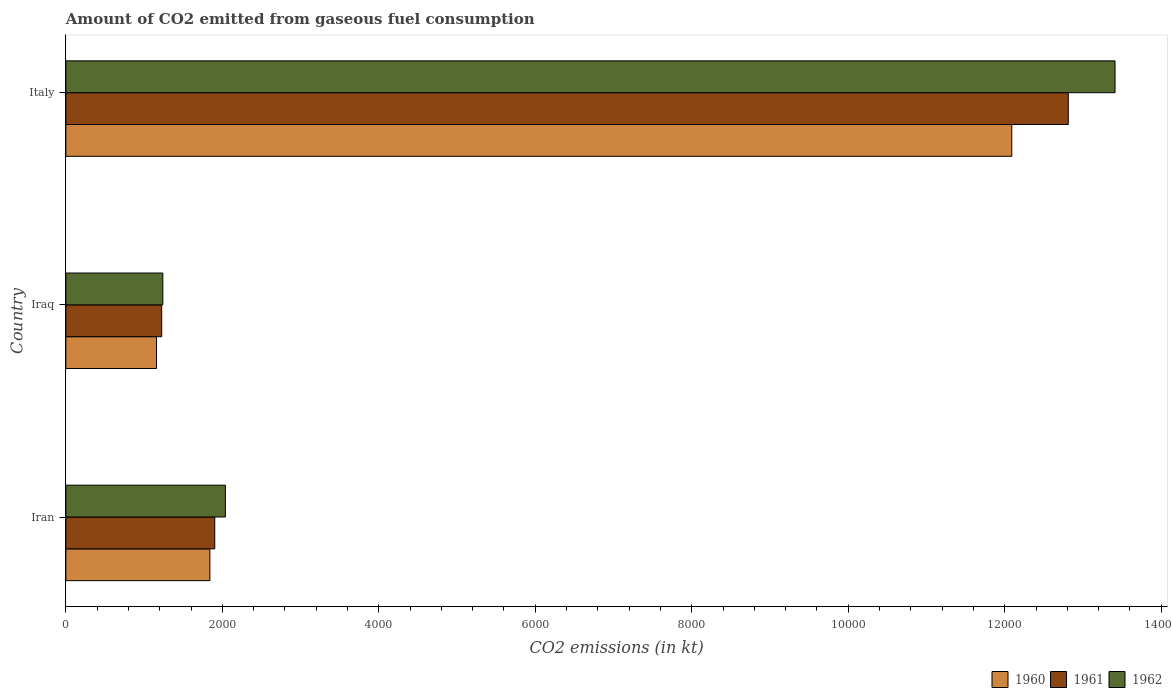How many different coloured bars are there?
Offer a very short reply. 3. In how many cases, is the number of bars for a given country not equal to the number of legend labels?
Ensure brevity in your answer.  0. What is the amount of CO2 emitted in 1962 in Iran?
Give a very brief answer. 2038.85. Across all countries, what is the maximum amount of CO2 emitted in 1960?
Your answer should be very brief. 1.21e+04. Across all countries, what is the minimum amount of CO2 emitted in 1960?
Provide a short and direct response. 1158.77. In which country was the amount of CO2 emitted in 1962 maximum?
Offer a very short reply. Italy. In which country was the amount of CO2 emitted in 1961 minimum?
Provide a succinct answer. Iraq. What is the total amount of CO2 emitted in 1962 in the graph?
Provide a short and direct response. 1.67e+04. What is the difference between the amount of CO2 emitted in 1962 in Iraq and that in Italy?
Keep it short and to the point. -1.22e+04. What is the difference between the amount of CO2 emitted in 1960 in Iraq and the amount of CO2 emitted in 1962 in Iran?
Give a very brief answer. -880.08. What is the average amount of CO2 emitted in 1961 per country?
Offer a very short reply. 5313.48. What is the difference between the amount of CO2 emitted in 1962 and amount of CO2 emitted in 1961 in Iraq?
Provide a short and direct response. 14.67. What is the ratio of the amount of CO2 emitted in 1960 in Iran to that in Iraq?
Ensure brevity in your answer.  1.59. Is the difference between the amount of CO2 emitted in 1962 in Iran and Iraq greater than the difference between the amount of CO2 emitted in 1961 in Iran and Iraq?
Give a very brief answer. Yes. What is the difference between the highest and the second highest amount of CO2 emitted in 1961?
Make the answer very short. 1.09e+04. What is the difference between the highest and the lowest amount of CO2 emitted in 1961?
Keep it short and to the point. 1.16e+04. What does the 2nd bar from the bottom in Iraq represents?
Offer a very short reply. 1961. Are all the bars in the graph horizontal?
Ensure brevity in your answer.  Yes. Does the graph contain any zero values?
Offer a terse response. No. How many legend labels are there?
Your answer should be compact. 3. How are the legend labels stacked?
Provide a short and direct response. Horizontal. What is the title of the graph?
Your answer should be very brief. Amount of CO2 emitted from gaseous fuel consumption. Does "1964" appear as one of the legend labels in the graph?
Provide a short and direct response. No. What is the label or title of the X-axis?
Make the answer very short. CO2 emissions (in kt). What is the CO2 emissions (in kt) in 1960 in Iran?
Keep it short and to the point. 1840.83. What is the CO2 emissions (in kt) in 1961 in Iran?
Your answer should be compact. 1903.17. What is the CO2 emissions (in kt) in 1962 in Iran?
Offer a terse response. 2038.85. What is the CO2 emissions (in kt) in 1960 in Iraq?
Your response must be concise. 1158.77. What is the CO2 emissions (in kt) of 1961 in Iraq?
Provide a short and direct response. 1224.78. What is the CO2 emissions (in kt) of 1962 in Iraq?
Ensure brevity in your answer.  1239.45. What is the CO2 emissions (in kt) of 1960 in Italy?
Keep it short and to the point. 1.21e+04. What is the CO2 emissions (in kt) of 1961 in Italy?
Give a very brief answer. 1.28e+04. What is the CO2 emissions (in kt) in 1962 in Italy?
Give a very brief answer. 1.34e+04. Across all countries, what is the maximum CO2 emissions (in kt) in 1960?
Keep it short and to the point. 1.21e+04. Across all countries, what is the maximum CO2 emissions (in kt) in 1961?
Keep it short and to the point. 1.28e+04. Across all countries, what is the maximum CO2 emissions (in kt) of 1962?
Your response must be concise. 1.34e+04. Across all countries, what is the minimum CO2 emissions (in kt) of 1960?
Offer a terse response. 1158.77. Across all countries, what is the minimum CO2 emissions (in kt) in 1961?
Your answer should be very brief. 1224.78. Across all countries, what is the minimum CO2 emissions (in kt) of 1962?
Provide a succinct answer. 1239.45. What is the total CO2 emissions (in kt) in 1960 in the graph?
Your answer should be very brief. 1.51e+04. What is the total CO2 emissions (in kt) of 1961 in the graph?
Offer a terse response. 1.59e+04. What is the total CO2 emissions (in kt) of 1962 in the graph?
Offer a very short reply. 1.67e+04. What is the difference between the CO2 emissions (in kt) in 1960 in Iran and that in Iraq?
Your answer should be very brief. 682.06. What is the difference between the CO2 emissions (in kt) in 1961 in Iran and that in Iraq?
Your answer should be compact. 678.39. What is the difference between the CO2 emissions (in kt) of 1962 in Iran and that in Iraq?
Your response must be concise. 799.41. What is the difference between the CO2 emissions (in kt) of 1960 in Iran and that in Italy?
Keep it short and to the point. -1.02e+04. What is the difference between the CO2 emissions (in kt) in 1961 in Iran and that in Italy?
Provide a succinct answer. -1.09e+04. What is the difference between the CO2 emissions (in kt) of 1962 in Iran and that in Italy?
Provide a short and direct response. -1.14e+04. What is the difference between the CO2 emissions (in kt) in 1960 in Iraq and that in Italy?
Give a very brief answer. -1.09e+04. What is the difference between the CO2 emissions (in kt) in 1961 in Iraq and that in Italy?
Make the answer very short. -1.16e+04. What is the difference between the CO2 emissions (in kt) in 1962 in Iraq and that in Italy?
Keep it short and to the point. -1.22e+04. What is the difference between the CO2 emissions (in kt) of 1960 in Iran and the CO2 emissions (in kt) of 1961 in Iraq?
Offer a very short reply. 616.06. What is the difference between the CO2 emissions (in kt) in 1960 in Iran and the CO2 emissions (in kt) in 1962 in Iraq?
Provide a succinct answer. 601.39. What is the difference between the CO2 emissions (in kt) in 1961 in Iran and the CO2 emissions (in kt) in 1962 in Iraq?
Provide a succinct answer. 663.73. What is the difference between the CO2 emissions (in kt) in 1960 in Iran and the CO2 emissions (in kt) in 1961 in Italy?
Your answer should be compact. -1.10e+04. What is the difference between the CO2 emissions (in kt) of 1960 in Iran and the CO2 emissions (in kt) of 1962 in Italy?
Provide a short and direct response. -1.16e+04. What is the difference between the CO2 emissions (in kt) in 1961 in Iran and the CO2 emissions (in kt) in 1962 in Italy?
Make the answer very short. -1.15e+04. What is the difference between the CO2 emissions (in kt) in 1960 in Iraq and the CO2 emissions (in kt) in 1961 in Italy?
Provide a short and direct response. -1.17e+04. What is the difference between the CO2 emissions (in kt) in 1960 in Iraq and the CO2 emissions (in kt) in 1962 in Italy?
Offer a very short reply. -1.23e+04. What is the difference between the CO2 emissions (in kt) in 1961 in Iraq and the CO2 emissions (in kt) in 1962 in Italy?
Ensure brevity in your answer.  -1.22e+04. What is the average CO2 emissions (in kt) of 1960 per country?
Your response must be concise. 5029.9. What is the average CO2 emissions (in kt) of 1961 per country?
Your answer should be compact. 5313.48. What is the average CO2 emissions (in kt) in 1962 per country?
Provide a succinct answer. 5562.84. What is the difference between the CO2 emissions (in kt) of 1960 and CO2 emissions (in kt) of 1961 in Iran?
Offer a very short reply. -62.34. What is the difference between the CO2 emissions (in kt) of 1960 and CO2 emissions (in kt) of 1962 in Iran?
Make the answer very short. -198.02. What is the difference between the CO2 emissions (in kt) of 1961 and CO2 emissions (in kt) of 1962 in Iran?
Your response must be concise. -135.68. What is the difference between the CO2 emissions (in kt) of 1960 and CO2 emissions (in kt) of 1961 in Iraq?
Make the answer very short. -66.01. What is the difference between the CO2 emissions (in kt) of 1960 and CO2 emissions (in kt) of 1962 in Iraq?
Provide a succinct answer. -80.67. What is the difference between the CO2 emissions (in kt) in 1961 and CO2 emissions (in kt) in 1962 in Iraq?
Your answer should be compact. -14.67. What is the difference between the CO2 emissions (in kt) of 1960 and CO2 emissions (in kt) of 1961 in Italy?
Make the answer very short. -722.4. What is the difference between the CO2 emissions (in kt) of 1960 and CO2 emissions (in kt) of 1962 in Italy?
Provide a succinct answer. -1320.12. What is the difference between the CO2 emissions (in kt) of 1961 and CO2 emissions (in kt) of 1962 in Italy?
Your answer should be very brief. -597.72. What is the ratio of the CO2 emissions (in kt) in 1960 in Iran to that in Iraq?
Provide a succinct answer. 1.59. What is the ratio of the CO2 emissions (in kt) of 1961 in Iran to that in Iraq?
Ensure brevity in your answer.  1.55. What is the ratio of the CO2 emissions (in kt) of 1962 in Iran to that in Iraq?
Your answer should be compact. 1.65. What is the ratio of the CO2 emissions (in kt) of 1960 in Iran to that in Italy?
Give a very brief answer. 0.15. What is the ratio of the CO2 emissions (in kt) in 1961 in Iran to that in Italy?
Keep it short and to the point. 0.15. What is the ratio of the CO2 emissions (in kt) of 1962 in Iran to that in Italy?
Your response must be concise. 0.15. What is the ratio of the CO2 emissions (in kt) in 1960 in Iraq to that in Italy?
Give a very brief answer. 0.1. What is the ratio of the CO2 emissions (in kt) in 1961 in Iraq to that in Italy?
Give a very brief answer. 0.1. What is the ratio of the CO2 emissions (in kt) of 1962 in Iraq to that in Italy?
Keep it short and to the point. 0.09. What is the difference between the highest and the second highest CO2 emissions (in kt) of 1960?
Your answer should be compact. 1.02e+04. What is the difference between the highest and the second highest CO2 emissions (in kt) in 1961?
Provide a short and direct response. 1.09e+04. What is the difference between the highest and the second highest CO2 emissions (in kt) of 1962?
Your answer should be very brief. 1.14e+04. What is the difference between the highest and the lowest CO2 emissions (in kt) in 1960?
Your answer should be compact. 1.09e+04. What is the difference between the highest and the lowest CO2 emissions (in kt) of 1961?
Ensure brevity in your answer.  1.16e+04. What is the difference between the highest and the lowest CO2 emissions (in kt) in 1962?
Ensure brevity in your answer.  1.22e+04. 